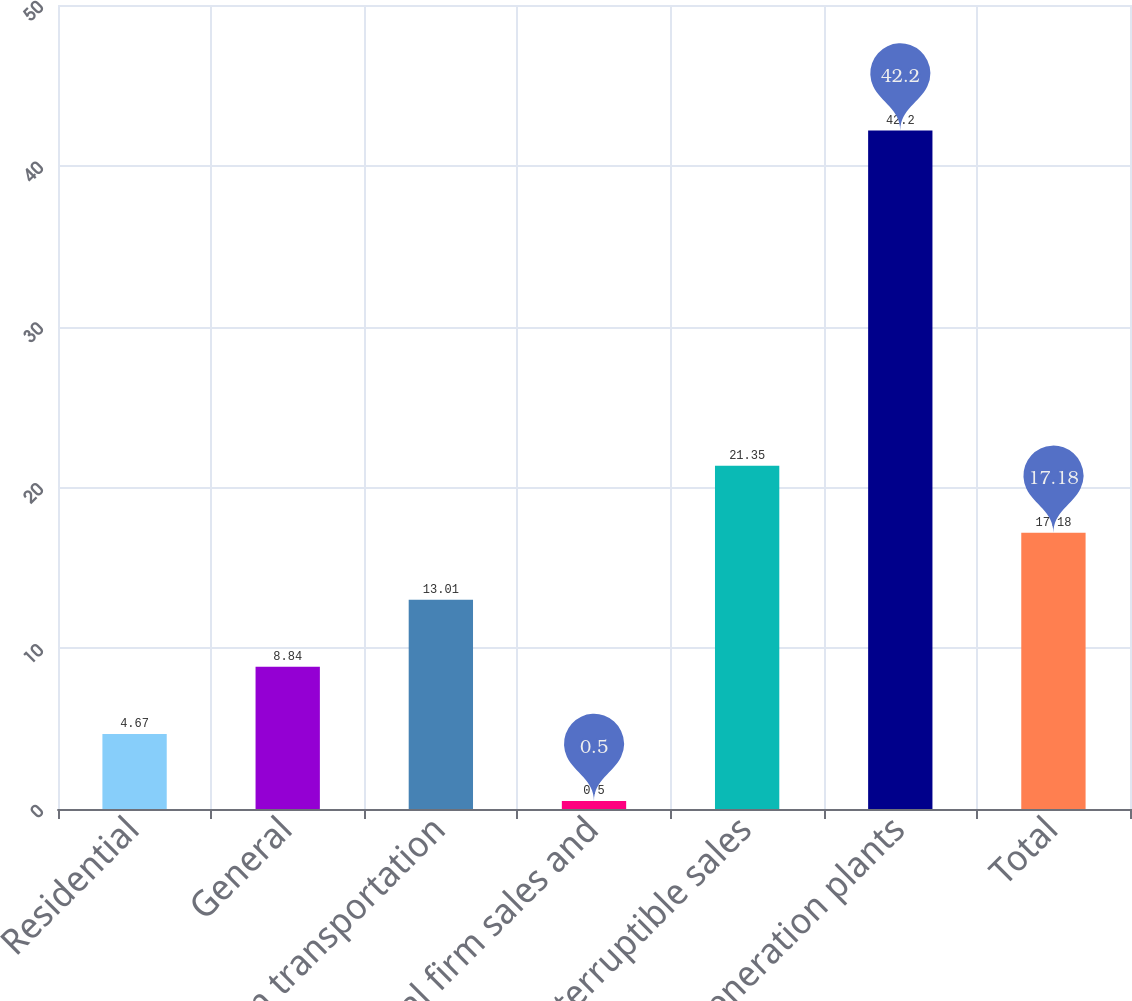Convert chart to OTSL. <chart><loc_0><loc_0><loc_500><loc_500><bar_chart><fcel>Residential<fcel>General<fcel>Firm transportation<fcel>Total firm sales and<fcel>Interruptible sales<fcel>Generation plants<fcel>Total<nl><fcel>4.67<fcel>8.84<fcel>13.01<fcel>0.5<fcel>21.35<fcel>42.2<fcel>17.18<nl></chart> 